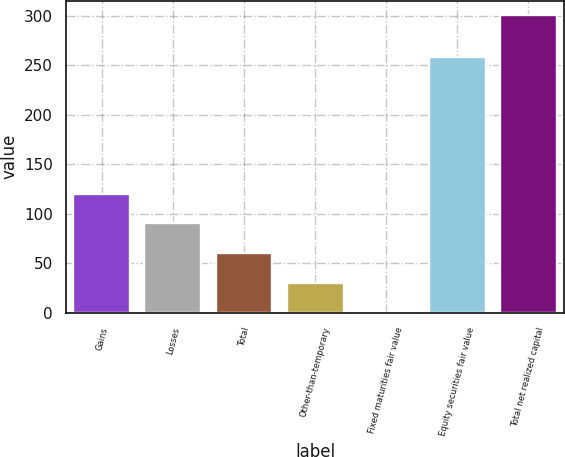<chart> <loc_0><loc_0><loc_500><loc_500><bar_chart><fcel>Gains<fcel>Losses<fcel>Total<fcel>Other-than-temporary<fcel>Fixed maturities fair value<fcel>Equity securities fair value<fcel>Total net realized capital<nl><fcel>120.26<fcel>90.27<fcel>60.28<fcel>30.29<fcel>0.3<fcel>258.6<fcel>300.2<nl></chart> 